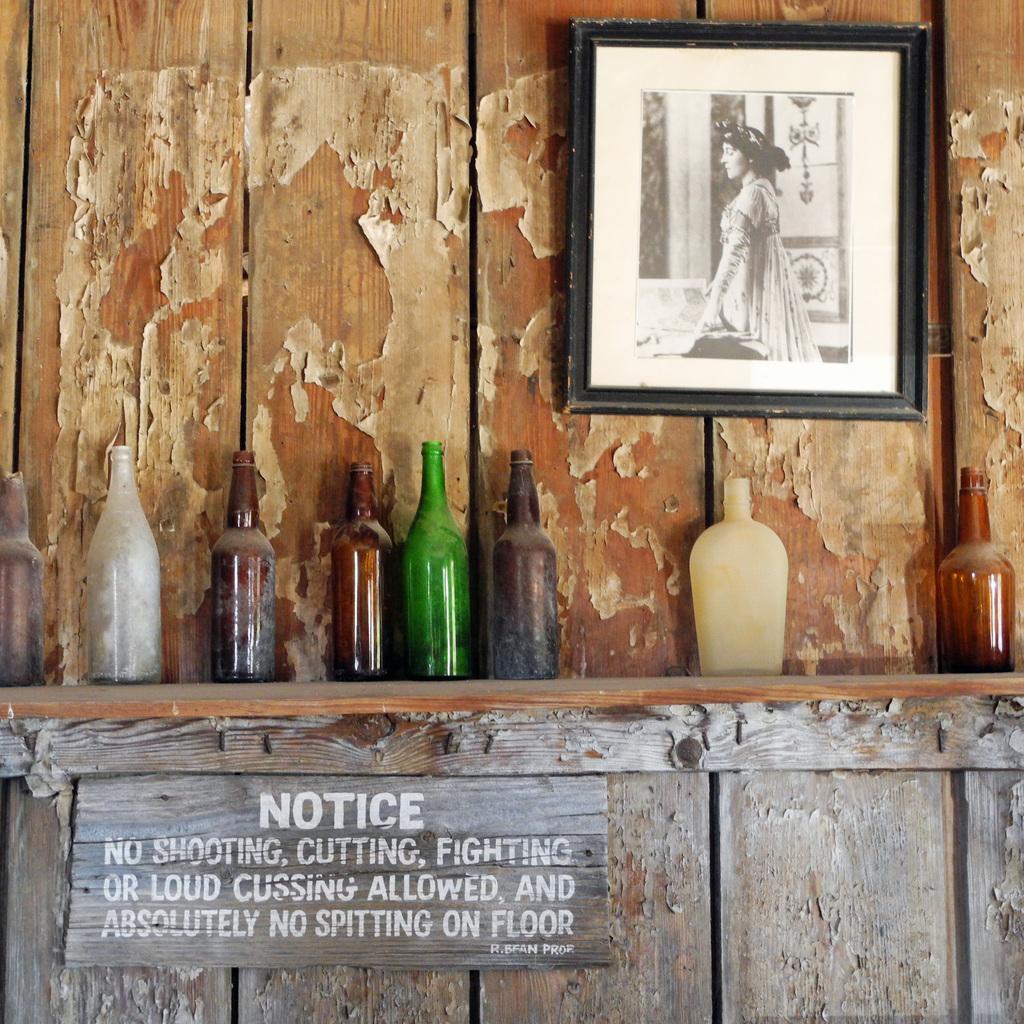Describe this image in one or two sentences. In the middle of the image there is wall. Top right side of the image there is a frame. Bottom left side of the image there is notice board. In the middle of the image there are some bottles. 